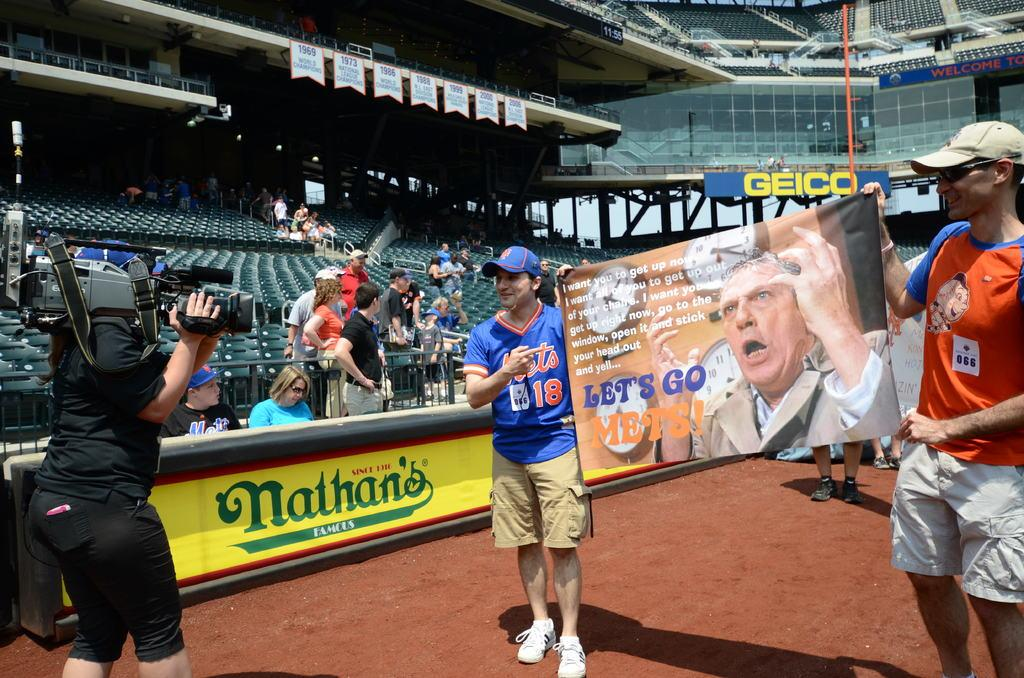<image>
Write a terse but informative summary of the picture. Several baseball fans hold up a sign that says Let's go Mets for the camera. 